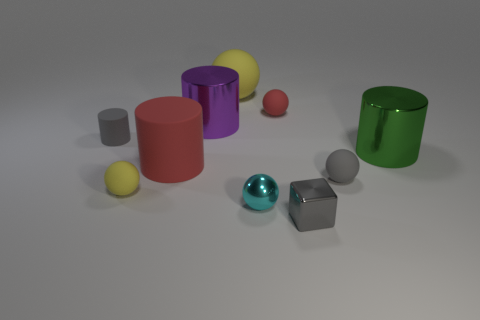Subtract 1 cylinders. How many cylinders are left? 3 Subtract all red balls. How many balls are left? 4 Subtract all large rubber balls. How many balls are left? 4 Subtract all green balls. Subtract all gray cubes. How many balls are left? 5 Subtract all blocks. How many objects are left? 9 Subtract 0 blue cylinders. How many objects are left? 10 Subtract all purple shiny things. Subtract all red cylinders. How many objects are left? 8 Add 2 tiny yellow rubber things. How many tiny yellow rubber things are left? 3 Add 4 red matte spheres. How many red matte spheres exist? 5 